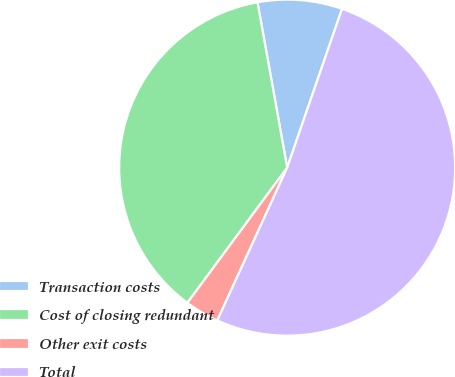<chart> <loc_0><loc_0><loc_500><loc_500><pie_chart><fcel>Transaction costs<fcel>Cost of closing redundant<fcel>Other exit costs<fcel>Total<nl><fcel>8.12%<fcel>37.05%<fcel>3.29%<fcel>51.53%<nl></chart> 